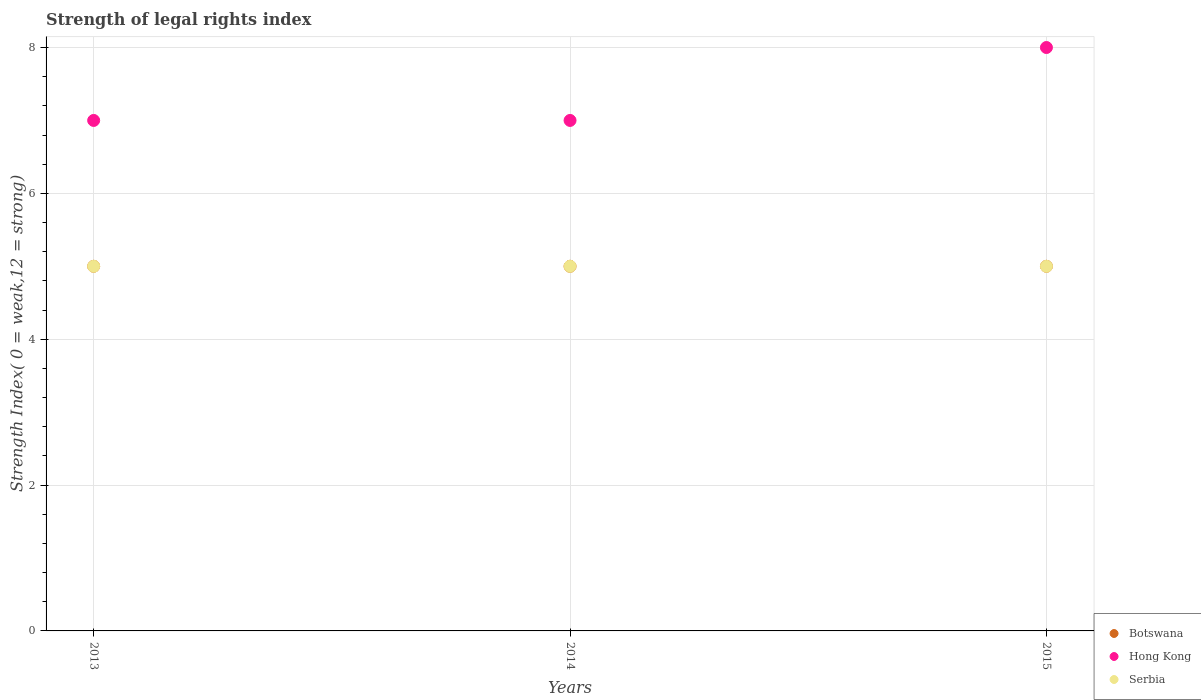How many different coloured dotlines are there?
Give a very brief answer. 3. What is the strength index in Hong Kong in 2015?
Provide a short and direct response. 8. Across all years, what is the maximum strength index in Botswana?
Your answer should be very brief. 5. Across all years, what is the minimum strength index in Botswana?
Ensure brevity in your answer.  5. In which year was the strength index in Serbia maximum?
Provide a succinct answer. 2013. What is the total strength index in Serbia in the graph?
Your response must be concise. 15. What is the difference between the strength index in Serbia in 2013 and that in 2014?
Keep it short and to the point. 0. What is the difference between the strength index in Hong Kong in 2015 and the strength index in Botswana in 2014?
Provide a short and direct response. 3. What is the average strength index in Hong Kong per year?
Offer a terse response. 7.33. In the year 2015, what is the difference between the strength index in Hong Kong and strength index in Serbia?
Your response must be concise. 3. In how many years, is the strength index in Hong Kong greater than 5.6?
Give a very brief answer. 3. What is the ratio of the strength index in Serbia in 2013 to that in 2014?
Make the answer very short. 1. Is the strength index in Botswana in 2014 less than that in 2015?
Provide a short and direct response. No. What is the difference between the highest and the second highest strength index in Hong Kong?
Give a very brief answer. 1. Is the sum of the strength index in Serbia in 2014 and 2015 greater than the maximum strength index in Botswana across all years?
Ensure brevity in your answer.  Yes. Does the strength index in Hong Kong monotonically increase over the years?
Give a very brief answer. No. Is the strength index in Botswana strictly less than the strength index in Serbia over the years?
Your answer should be very brief. No. How many years are there in the graph?
Your answer should be very brief. 3. What is the difference between two consecutive major ticks on the Y-axis?
Provide a short and direct response. 2. Are the values on the major ticks of Y-axis written in scientific E-notation?
Ensure brevity in your answer.  No. Does the graph contain any zero values?
Make the answer very short. No. Does the graph contain grids?
Ensure brevity in your answer.  Yes. Where does the legend appear in the graph?
Provide a short and direct response. Bottom right. How many legend labels are there?
Provide a succinct answer. 3. How are the legend labels stacked?
Provide a succinct answer. Vertical. What is the title of the graph?
Keep it short and to the point. Strength of legal rights index. Does "Nepal" appear as one of the legend labels in the graph?
Keep it short and to the point. No. What is the label or title of the X-axis?
Your answer should be compact. Years. What is the label or title of the Y-axis?
Your answer should be compact. Strength Index( 0 = weak,12 = strong). What is the Strength Index( 0 = weak,12 = strong) in Botswana in 2014?
Provide a short and direct response. 5. What is the Strength Index( 0 = weak,12 = strong) in Serbia in 2014?
Offer a very short reply. 5. What is the Strength Index( 0 = weak,12 = strong) of Serbia in 2015?
Ensure brevity in your answer.  5. Across all years, what is the maximum Strength Index( 0 = weak,12 = strong) in Botswana?
Offer a terse response. 5. Across all years, what is the maximum Strength Index( 0 = weak,12 = strong) in Hong Kong?
Offer a very short reply. 8. Across all years, what is the maximum Strength Index( 0 = weak,12 = strong) in Serbia?
Offer a very short reply. 5. Across all years, what is the minimum Strength Index( 0 = weak,12 = strong) in Hong Kong?
Your answer should be very brief. 7. What is the total Strength Index( 0 = weak,12 = strong) of Botswana in the graph?
Provide a short and direct response. 15. What is the total Strength Index( 0 = weak,12 = strong) of Serbia in the graph?
Provide a succinct answer. 15. What is the difference between the Strength Index( 0 = weak,12 = strong) of Hong Kong in 2013 and that in 2014?
Your answer should be compact. 0. What is the difference between the Strength Index( 0 = weak,12 = strong) in Serbia in 2013 and that in 2014?
Your answer should be compact. 0. What is the difference between the Strength Index( 0 = weak,12 = strong) of Botswana in 2014 and that in 2015?
Your answer should be compact. 0. What is the difference between the Strength Index( 0 = weak,12 = strong) of Serbia in 2014 and that in 2015?
Provide a short and direct response. 0. What is the difference between the Strength Index( 0 = weak,12 = strong) in Botswana in 2013 and the Strength Index( 0 = weak,12 = strong) in Hong Kong in 2014?
Offer a very short reply. -2. What is the difference between the Strength Index( 0 = weak,12 = strong) in Botswana in 2013 and the Strength Index( 0 = weak,12 = strong) in Serbia in 2014?
Ensure brevity in your answer.  0. What is the difference between the Strength Index( 0 = weak,12 = strong) of Hong Kong in 2013 and the Strength Index( 0 = weak,12 = strong) of Serbia in 2014?
Give a very brief answer. 2. What is the difference between the Strength Index( 0 = weak,12 = strong) of Botswana in 2013 and the Strength Index( 0 = weak,12 = strong) of Hong Kong in 2015?
Your response must be concise. -3. What is the difference between the Strength Index( 0 = weak,12 = strong) of Botswana in 2013 and the Strength Index( 0 = weak,12 = strong) of Serbia in 2015?
Offer a terse response. 0. What is the difference between the Strength Index( 0 = weak,12 = strong) in Hong Kong in 2013 and the Strength Index( 0 = weak,12 = strong) in Serbia in 2015?
Provide a succinct answer. 2. What is the difference between the Strength Index( 0 = weak,12 = strong) in Botswana in 2014 and the Strength Index( 0 = weak,12 = strong) in Serbia in 2015?
Ensure brevity in your answer.  0. What is the difference between the Strength Index( 0 = weak,12 = strong) of Hong Kong in 2014 and the Strength Index( 0 = weak,12 = strong) of Serbia in 2015?
Your response must be concise. 2. What is the average Strength Index( 0 = weak,12 = strong) in Botswana per year?
Your response must be concise. 5. What is the average Strength Index( 0 = weak,12 = strong) in Hong Kong per year?
Give a very brief answer. 7.33. What is the average Strength Index( 0 = weak,12 = strong) in Serbia per year?
Provide a short and direct response. 5. In the year 2013, what is the difference between the Strength Index( 0 = weak,12 = strong) of Botswana and Strength Index( 0 = weak,12 = strong) of Hong Kong?
Offer a terse response. -2. In the year 2013, what is the difference between the Strength Index( 0 = weak,12 = strong) of Botswana and Strength Index( 0 = weak,12 = strong) of Serbia?
Your answer should be very brief. 0. In the year 2014, what is the difference between the Strength Index( 0 = weak,12 = strong) of Botswana and Strength Index( 0 = weak,12 = strong) of Serbia?
Your answer should be very brief. 0. In the year 2014, what is the difference between the Strength Index( 0 = weak,12 = strong) of Hong Kong and Strength Index( 0 = weak,12 = strong) of Serbia?
Your answer should be very brief. 2. What is the ratio of the Strength Index( 0 = weak,12 = strong) of Botswana in 2013 to that in 2014?
Your answer should be compact. 1. What is the ratio of the Strength Index( 0 = weak,12 = strong) of Serbia in 2013 to that in 2014?
Provide a succinct answer. 1. What is the ratio of the Strength Index( 0 = weak,12 = strong) in Botswana in 2014 to that in 2015?
Keep it short and to the point. 1. What is the ratio of the Strength Index( 0 = weak,12 = strong) in Serbia in 2014 to that in 2015?
Keep it short and to the point. 1. What is the difference between the highest and the second highest Strength Index( 0 = weak,12 = strong) of Hong Kong?
Make the answer very short. 1. What is the difference between the highest and the lowest Strength Index( 0 = weak,12 = strong) of Botswana?
Give a very brief answer. 0. What is the difference between the highest and the lowest Strength Index( 0 = weak,12 = strong) in Hong Kong?
Offer a terse response. 1. 